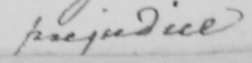Please provide the text content of this handwritten line. prejudice 